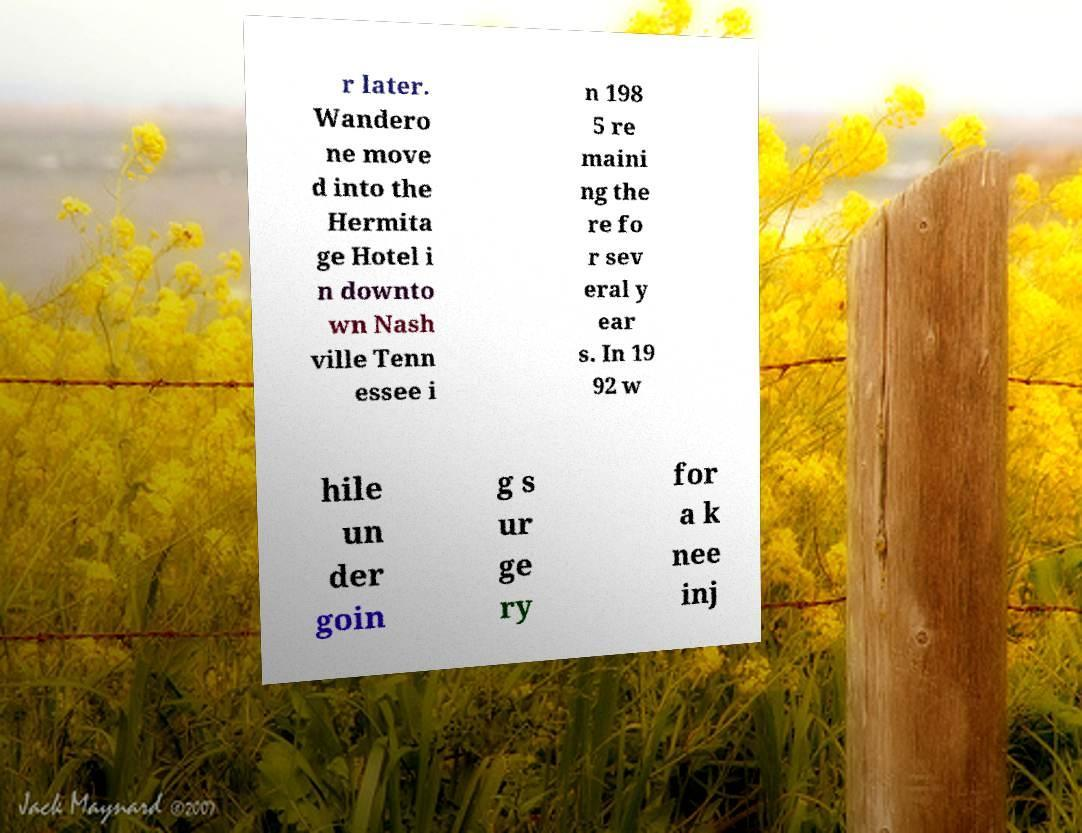What messages or text are displayed in this image? I need them in a readable, typed format. r later. Wandero ne move d into the Hermita ge Hotel i n downto wn Nash ville Tenn essee i n 198 5 re maini ng the re fo r sev eral y ear s. In 19 92 w hile un der goin g s ur ge ry for a k nee inj 